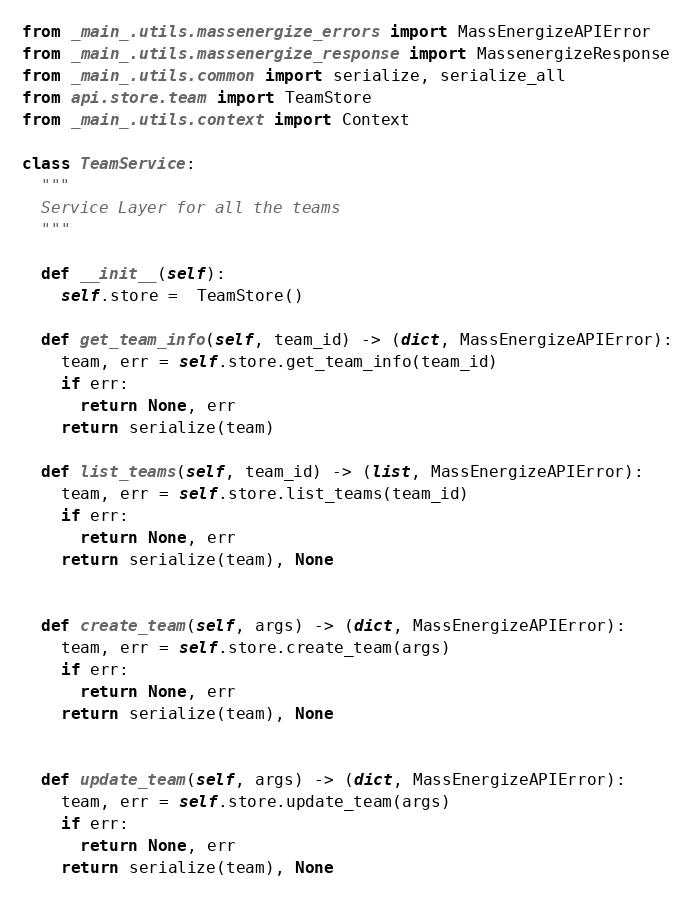Convert code to text. <code><loc_0><loc_0><loc_500><loc_500><_Python_>from _main_.utils.massenergize_errors import MassEnergizeAPIError
from _main_.utils.massenergize_response import MassenergizeResponse
from _main_.utils.common import serialize, serialize_all
from api.store.team import TeamStore
from _main_.utils.context import Context

class TeamService:
  """
  Service Layer for all the teams
  """

  def __init__(self):
    self.store =  TeamStore()

  def get_team_info(self, team_id) -> (dict, MassEnergizeAPIError):
    team, err = self.store.get_team_info(team_id)
    if err:
      return None, err
    return serialize(team)

  def list_teams(self, team_id) -> (list, MassEnergizeAPIError):
    team, err = self.store.list_teams(team_id)
    if err:
      return None, err
    return serialize(team), None


  def create_team(self, args) -> (dict, MassEnergizeAPIError):
    team, err = self.store.create_team(args)
    if err:
      return None, err
    return serialize(team), None


  def update_team(self, args) -> (dict, MassEnergizeAPIError):
    team, err = self.store.update_team(args)
    if err:
      return None, err
    return serialize(team), None
</code> 